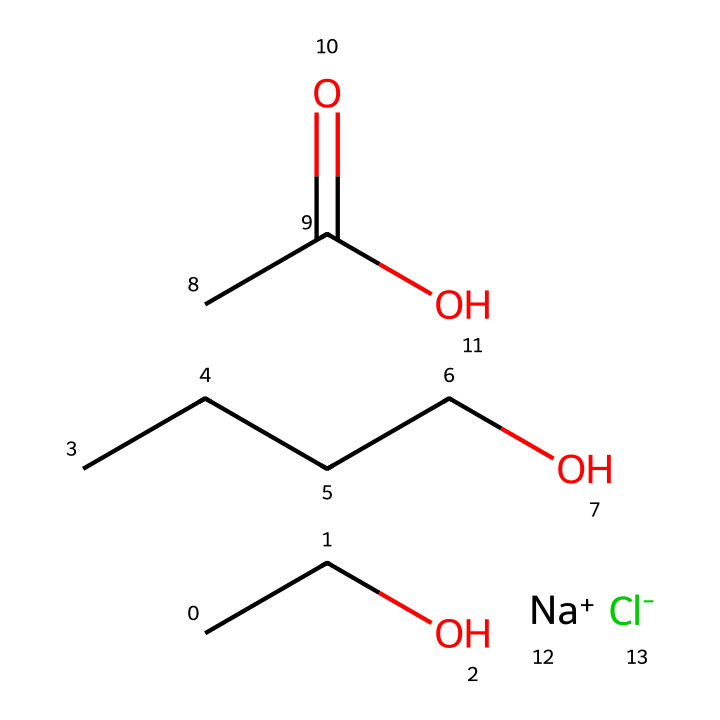what is the total number of carbon atoms in this molecule? The SMILES representation indicates there are multiple carbon chains. Analyzing the segments, CCO contains 2 carbons, CCCCO contains 5 carbons, and CC(=O)O contributes another 2. Adding them gives a total of 2 + 5 + 2 = 9 carbon atoms.
Answer: nine how many hydrogen atoms are present in this chemical? To find the number of hydrogen atoms, we need to consider the carbon chains and the functional groups. The molecule contains 9 carbon atoms (each bonded to hydrogen, with some saturation impacted by functional groups). Counting the bonds reveals there are 18 hydrogen atoms attached to the carbon structure after considering connectivity rules and functional groups.
Answer: eighteen what type of functional group is present in this molecule? Upon examining the structure, specifically the CC(=O)O part, we can identify that it contains a carboxylic acid functional group, characterized by a -COOH configuration.
Answer: carboxylic acid which ions in this molecule contribute to its electrolyte properties? The presence of "[Na+]" and "[Cl-]" in the SMILES representation indicates that sodium and chloride ions are present. These ions are essential for the electrolyte properties of the solution, as they dissociate in the solution to conduct electricity.
Answer: sodium and chloride what role does the carboxylic acid play in this cleaning solution? The carboxylic acid group acts as a surfactant, helping to lower the surface tension of water in the cleaning solution, which enhances its ability to penetrate and lift away dirt, grease, and grime. This functional group also aids in solubility in water, making the solution effective for cleaning.
Answer: surfactant how does the presence of sodium ions affect the solution's conductivity? Sodium ions increase the conductivity of the solution by providing free-moving charged particles. In an electrolyte, the balance between cations and anions (in this case, sodium and chloride) allows for greater ion mobility, enhancing the overall conductivity of the solution.
Answer: increases conductivity 